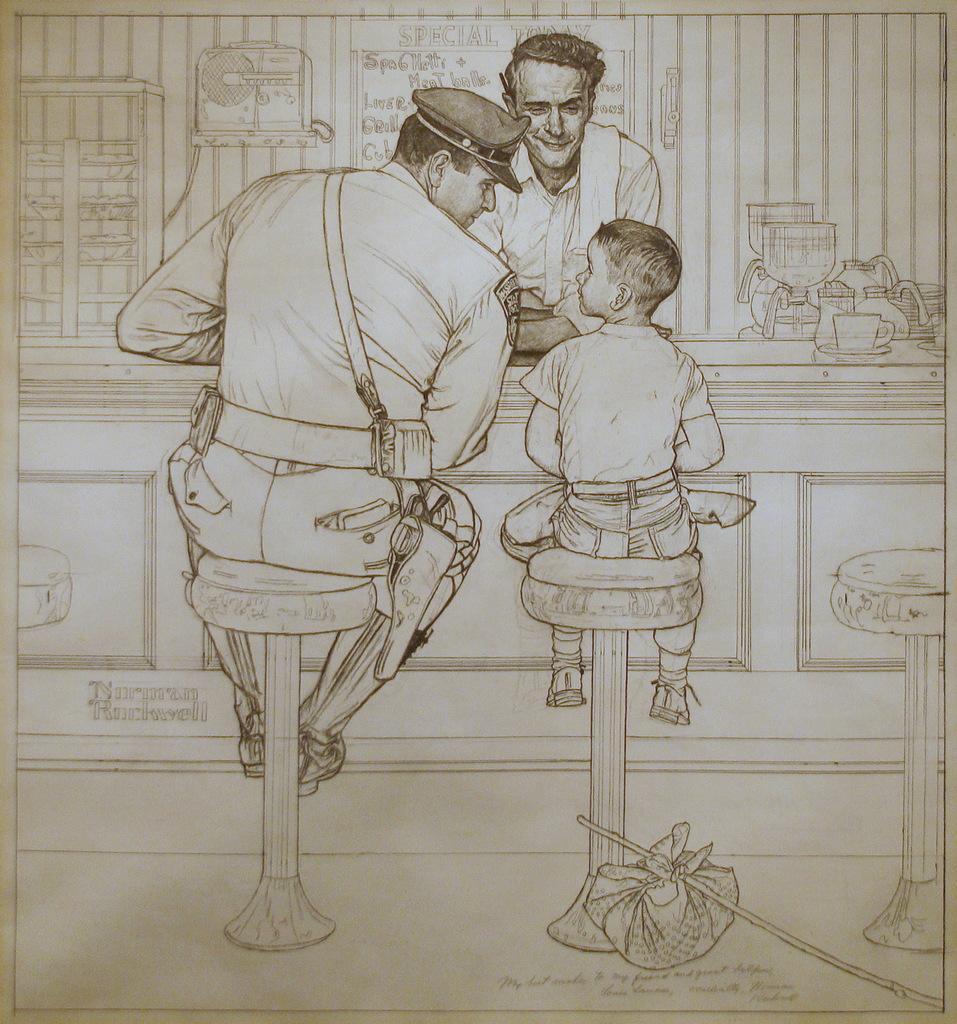How would you summarize this image in a sentence or two? In this picture we can see drawing of people, chairs, text and objects. 